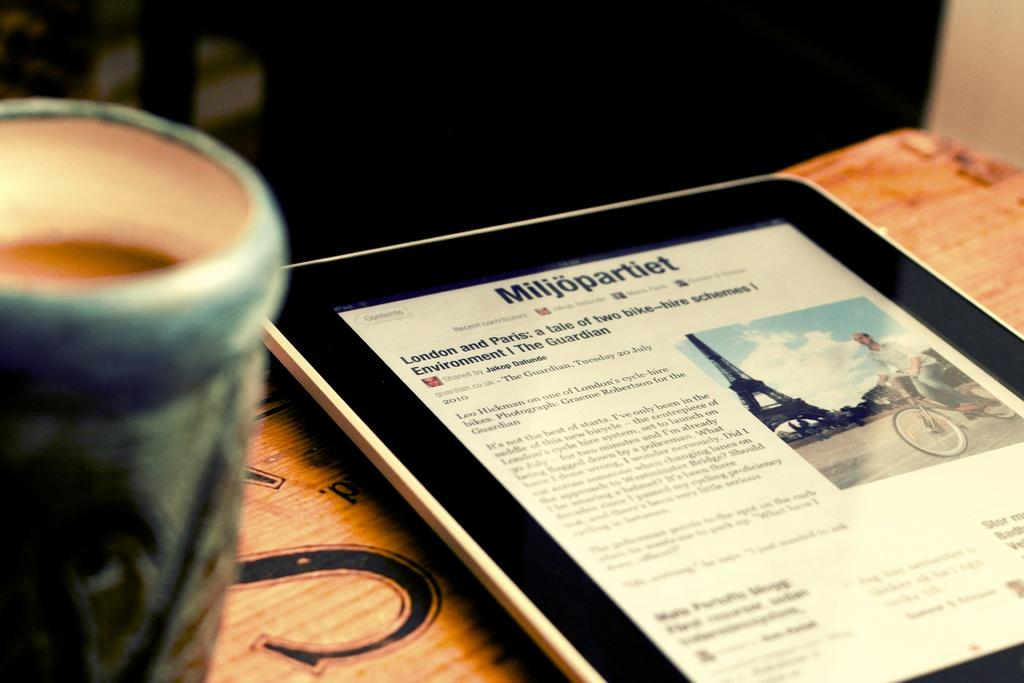<image>
Write a terse but informative summary of the picture. Black ipad on a table with a Milijopartiet website pulled up 